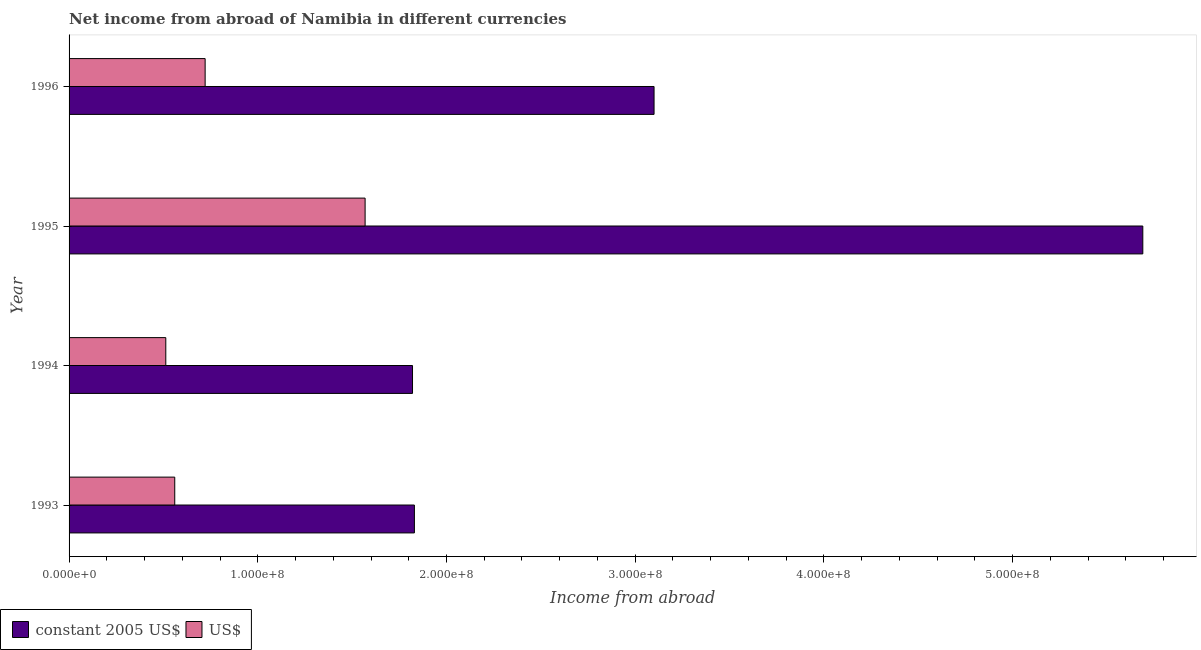How many different coloured bars are there?
Your answer should be compact. 2. Are the number of bars per tick equal to the number of legend labels?
Your response must be concise. Yes. What is the label of the 3rd group of bars from the top?
Your response must be concise. 1994. In how many cases, is the number of bars for a given year not equal to the number of legend labels?
Your answer should be compact. 0. What is the income from abroad in constant 2005 us$ in 1993?
Offer a terse response. 1.83e+08. Across all years, what is the maximum income from abroad in us$?
Offer a terse response. 1.57e+08. Across all years, what is the minimum income from abroad in us$?
Provide a succinct answer. 5.13e+07. In which year was the income from abroad in us$ maximum?
Ensure brevity in your answer.  1995. What is the total income from abroad in us$ in the graph?
Provide a short and direct response. 3.36e+08. What is the difference between the income from abroad in constant 2005 us$ in 1993 and that in 1994?
Give a very brief answer. 1.00e+06. What is the difference between the income from abroad in constant 2005 us$ in 1995 and the income from abroad in us$ in 1993?
Provide a short and direct response. 5.13e+08. What is the average income from abroad in constant 2005 us$ per year?
Your answer should be compact. 3.11e+08. In the year 1995, what is the difference between the income from abroad in constant 2005 us$ and income from abroad in us$?
Offer a terse response. 4.12e+08. What is the ratio of the income from abroad in constant 2005 us$ in 1994 to that in 1995?
Your answer should be very brief. 0.32. Is the difference between the income from abroad in constant 2005 us$ in 1994 and 1995 greater than the difference between the income from abroad in us$ in 1994 and 1995?
Provide a short and direct response. No. What is the difference between the highest and the second highest income from abroad in us$?
Offer a terse response. 8.48e+07. What is the difference between the highest and the lowest income from abroad in us$?
Provide a succinct answer. 1.06e+08. What does the 2nd bar from the top in 1996 represents?
Give a very brief answer. Constant 2005 us$. What does the 1st bar from the bottom in 1993 represents?
Provide a succinct answer. Constant 2005 us$. How many bars are there?
Your answer should be very brief. 8. Does the graph contain grids?
Offer a very short reply. No. What is the title of the graph?
Provide a succinct answer. Net income from abroad of Namibia in different currencies. Does "UN agencies" appear as one of the legend labels in the graph?
Keep it short and to the point. No. What is the label or title of the X-axis?
Your answer should be compact. Income from abroad. What is the label or title of the Y-axis?
Make the answer very short. Year. What is the Income from abroad in constant 2005 US$ in 1993?
Offer a terse response. 1.83e+08. What is the Income from abroad of US$ in 1993?
Provide a short and direct response. 5.60e+07. What is the Income from abroad of constant 2005 US$ in 1994?
Give a very brief answer. 1.82e+08. What is the Income from abroad in US$ in 1994?
Offer a very short reply. 5.13e+07. What is the Income from abroad in constant 2005 US$ in 1995?
Ensure brevity in your answer.  5.69e+08. What is the Income from abroad in US$ in 1995?
Your response must be concise. 1.57e+08. What is the Income from abroad of constant 2005 US$ in 1996?
Your answer should be very brief. 3.10e+08. What is the Income from abroad in US$ in 1996?
Offer a very short reply. 7.21e+07. Across all years, what is the maximum Income from abroad of constant 2005 US$?
Your response must be concise. 5.69e+08. Across all years, what is the maximum Income from abroad in US$?
Your response must be concise. 1.57e+08. Across all years, what is the minimum Income from abroad of constant 2005 US$?
Ensure brevity in your answer.  1.82e+08. Across all years, what is the minimum Income from abroad in US$?
Your response must be concise. 5.13e+07. What is the total Income from abroad in constant 2005 US$ in the graph?
Your response must be concise. 1.24e+09. What is the total Income from abroad of US$ in the graph?
Your answer should be compact. 3.36e+08. What is the difference between the Income from abroad in US$ in 1993 and that in 1994?
Your response must be concise. 4.75e+06. What is the difference between the Income from abroad in constant 2005 US$ in 1993 and that in 1995?
Your response must be concise. -3.86e+08. What is the difference between the Income from abroad of US$ in 1993 and that in 1995?
Provide a short and direct response. -1.01e+08. What is the difference between the Income from abroad of constant 2005 US$ in 1993 and that in 1996?
Offer a very short reply. -1.27e+08. What is the difference between the Income from abroad of US$ in 1993 and that in 1996?
Your response must be concise. -1.61e+07. What is the difference between the Income from abroad of constant 2005 US$ in 1994 and that in 1995?
Your response must be concise. -3.87e+08. What is the difference between the Income from abroad of US$ in 1994 and that in 1995?
Your response must be concise. -1.06e+08. What is the difference between the Income from abroad in constant 2005 US$ in 1994 and that in 1996?
Your answer should be compact. -1.28e+08. What is the difference between the Income from abroad in US$ in 1994 and that in 1996?
Offer a terse response. -2.08e+07. What is the difference between the Income from abroad in constant 2005 US$ in 1995 and that in 1996?
Offer a terse response. 2.59e+08. What is the difference between the Income from abroad in US$ in 1995 and that in 1996?
Make the answer very short. 8.48e+07. What is the difference between the Income from abroad of constant 2005 US$ in 1993 and the Income from abroad of US$ in 1994?
Provide a succinct answer. 1.32e+08. What is the difference between the Income from abroad in constant 2005 US$ in 1993 and the Income from abroad in US$ in 1995?
Offer a terse response. 2.61e+07. What is the difference between the Income from abroad in constant 2005 US$ in 1993 and the Income from abroad in US$ in 1996?
Ensure brevity in your answer.  1.11e+08. What is the difference between the Income from abroad of constant 2005 US$ in 1994 and the Income from abroad of US$ in 1995?
Provide a succinct answer. 2.51e+07. What is the difference between the Income from abroad in constant 2005 US$ in 1994 and the Income from abroad in US$ in 1996?
Offer a very short reply. 1.10e+08. What is the difference between the Income from abroad of constant 2005 US$ in 1995 and the Income from abroad of US$ in 1996?
Make the answer very short. 4.97e+08. What is the average Income from abroad of constant 2005 US$ per year?
Give a very brief answer. 3.11e+08. What is the average Income from abroad in US$ per year?
Your answer should be compact. 8.41e+07. In the year 1993, what is the difference between the Income from abroad of constant 2005 US$ and Income from abroad of US$?
Your answer should be compact. 1.27e+08. In the year 1994, what is the difference between the Income from abroad in constant 2005 US$ and Income from abroad in US$?
Offer a terse response. 1.31e+08. In the year 1995, what is the difference between the Income from abroad in constant 2005 US$ and Income from abroad in US$?
Give a very brief answer. 4.12e+08. In the year 1996, what is the difference between the Income from abroad of constant 2005 US$ and Income from abroad of US$?
Offer a terse response. 2.38e+08. What is the ratio of the Income from abroad in US$ in 1993 to that in 1994?
Your response must be concise. 1.09. What is the ratio of the Income from abroad of constant 2005 US$ in 1993 to that in 1995?
Keep it short and to the point. 0.32. What is the ratio of the Income from abroad of US$ in 1993 to that in 1995?
Your answer should be very brief. 0.36. What is the ratio of the Income from abroad in constant 2005 US$ in 1993 to that in 1996?
Provide a short and direct response. 0.59. What is the ratio of the Income from abroad of US$ in 1993 to that in 1996?
Your answer should be compact. 0.78. What is the ratio of the Income from abroad of constant 2005 US$ in 1994 to that in 1995?
Make the answer very short. 0.32. What is the ratio of the Income from abroad of US$ in 1994 to that in 1995?
Ensure brevity in your answer.  0.33. What is the ratio of the Income from abroad in constant 2005 US$ in 1994 to that in 1996?
Offer a terse response. 0.59. What is the ratio of the Income from abroad in US$ in 1994 to that in 1996?
Offer a terse response. 0.71. What is the ratio of the Income from abroad of constant 2005 US$ in 1995 to that in 1996?
Your answer should be compact. 1.84. What is the ratio of the Income from abroad of US$ in 1995 to that in 1996?
Offer a very short reply. 2.18. What is the difference between the highest and the second highest Income from abroad of constant 2005 US$?
Offer a very short reply. 2.59e+08. What is the difference between the highest and the second highest Income from abroad of US$?
Offer a very short reply. 8.48e+07. What is the difference between the highest and the lowest Income from abroad in constant 2005 US$?
Give a very brief answer. 3.87e+08. What is the difference between the highest and the lowest Income from abroad of US$?
Make the answer very short. 1.06e+08. 